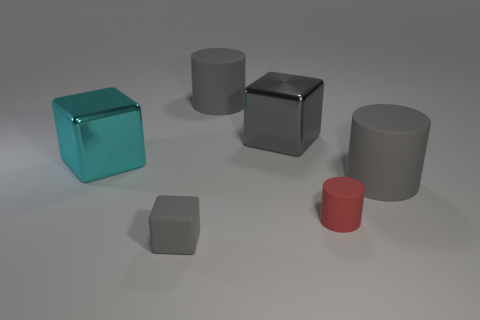Subtract all gray metal cubes. How many cubes are left? 2 Add 1 large rubber things. How many objects exist? 7 Subtract all cyan cubes. How many cubes are left? 2 Subtract 1 cubes. How many cubes are left? 2 Add 1 large cylinders. How many large cylinders are left? 3 Add 2 gray rubber blocks. How many gray rubber blocks exist? 3 Subtract 0 brown cylinders. How many objects are left? 6 Subtract all red cubes. Subtract all purple cylinders. How many cubes are left? 3 Subtract all blue cylinders. How many brown blocks are left? 0 Subtract all tiny gray rubber cylinders. Subtract all gray rubber cubes. How many objects are left? 5 